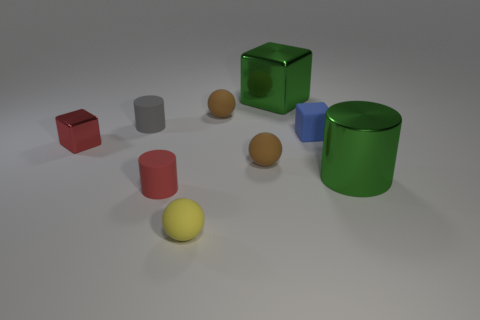What size is the red cylinder that is made of the same material as the blue cube?
Your answer should be compact. Small. How big is the red object in front of the large green shiny thing to the right of the big green thing that is behind the red metallic thing?
Provide a succinct answer. Small. What is the size of the shiny object that is in front of the tiny metal cube?
Your answer should be compact. Large. What number of cyan things are either shiny cylinders or metallic objects?
Your answer should be compact. 0. Is there a matte block of the same size as the red matte thing?
Your response must be concise. Yes. There is a blue thing that is the same size as the red cube; what is its material?
Offer a terse response. Rubber. Does the cylinder behind the small blue matte cube have the same size as the green metallic thing that is in front of the tiny gray cylinder?
Provide a succinct answer. No. What number of objects are red shiny blocks or cylinders right of the gray thing?
Keep it short and to the point. 3. Is there a cyan metallic object that has the same shape as the blue matte object?
Your response must be concise. No. How big is the brown matte thing that is in front of the small cube on the right side of the tiny yellow rubber sphere?
Provide a succinct answer. Small. 